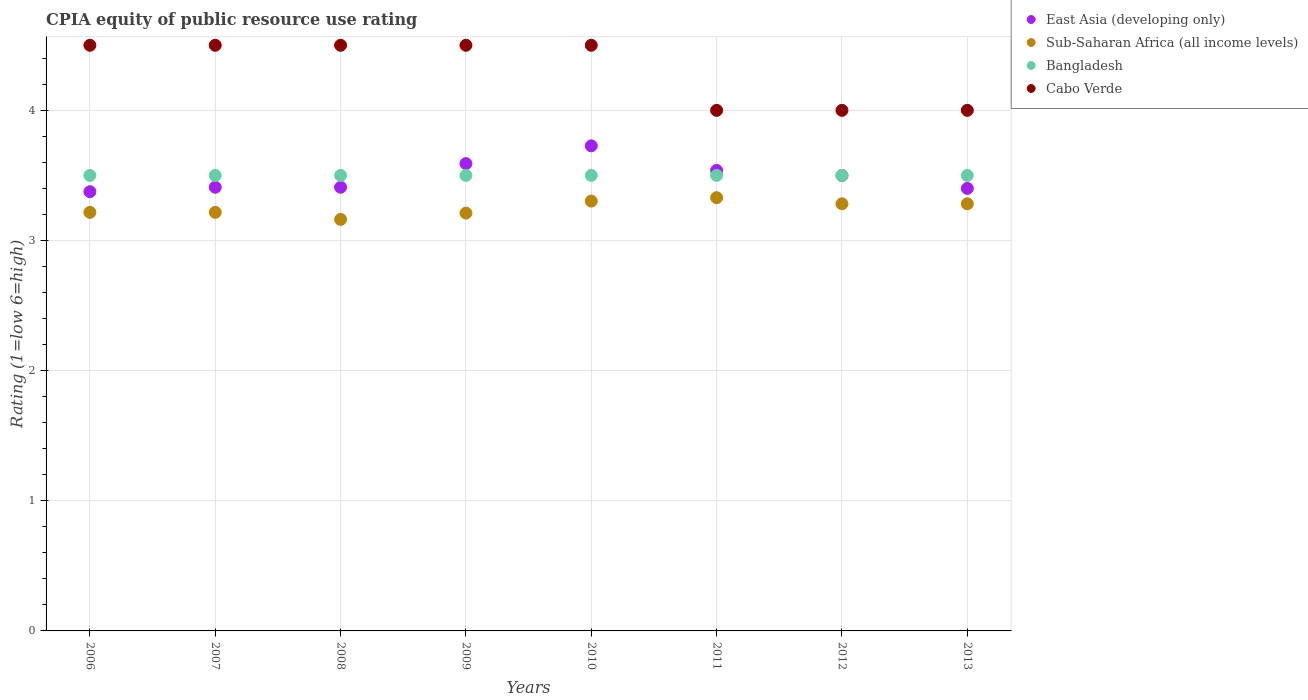How many different coloured dotlines are there?
Provide a short and direct response. 4. Is the number of dotlines equal to the number of legend labels?
Give a very brief answer. Yes. What is the CPIA rating in Sub-Saharan Africa (all income levels) in 2009?
Offer a terse response. 3.21. Across all years, what is the minimum CPIA rating in Sub-Saharan Africa (all income levels)?
Your answer should be compact. 3.16. In which year was the CPIA rating in Bangladesh maximum?
Give a very brief answer. 2006. What is the total CPIA rating in East Asia (developing only) in the graph?
Your response must be concise. 27.95. What is the difference between the CPIA rating in Bangladesh in 2011 and the CPIA rating in Cabo Verde in 2012?
Ensure brevity in your answer.  -0.5. What is the average CPIA rating in Sub-Saharan Africa (all income levels) per year?
Provide a short and direct response. 3.25. In the year 2008, what is the difference between the CPIA rating in Bangladesh and CPIA rating in East Asia (developing only)?
Offer a very short reply. 0.09. In how many years, is the CPIA rating in Cabo Verde greater than 1.8?
Your answer should be very brief. 8. What is the ratio of the CPIA rating in Sub-Saharan Africa (all income levels) in 2007 to that in 2009?
Give a very brief answer. 1. Is the CPIA rating in East Asia (developing only) in 2008 less than that in 2012?
Ensure brevity in your answer.  Yes. Is the difference between the CPIA rating in Bangladesh in 2008 and 2012 greater than the difference between the CPIA rating in East Asia (developing only) in 2008 and 2012?
Provide a succinct answer. Yes. What is the difference between the highest and the second highest CPIA rating in East Asia (developing only)?
Your answer should be very brief. 0.14. Is it the case that in every year, the sum of the CPIA rating in Bangladesh and CPIA rating in Cabo Verde  is greater than the sum of CPIA rating in East Asia (developing only) and CPIA rating in Sub-Saharan Africa (all income levels)?
Offer a very short reply. Yes. Is it the case that in every year, the sum of the CPIA rating in East Asia (developing only) and CPIA rating in Sub-Saharan Africa (all income levels)  is greater than the CPIA rating in Bangladesh?
Your response must be concise. Yes. Is the CPIA rating in Sub-Saharan Africa (all income levels) strictly greater than the CPIA rating in Bangladesh over the years?
Provide a succinct answer. No. Is the CPIA rating in Bangladesh strictly less than the CPIA rating in Cabo Verde over the years?
Make the answer very short. Yes. How many dotlines are there?
Your response must be concise. 4. How many years are there in the graph?
Keep it short and to the point. 8. Are the values on the major ticks of Y-axis written in scientific E-notation?
Your answer should be compact. No. Does the graph contain any zero values?
Provide a succinct answer. No. Does the graph contain grids?
Your answer should be very brief. Yes. What is the title of the graph?
Provide a succinct answer. CPIA equity of public resource use rating. Does "United States" appear as one of the legend labels in the graph?
Offer a very short reply. No. What is the label or title of the X-axis?
Make the answer very short. Years. What is the label or title of the Y-axis?
Give a very brief answer. Rating (1=low 6=high). What is the Rating (1=low 6=high) of East Asia (developing only) in 2006?
Make the answer very short. 3.38. What is the Rating (1=low 6=high) of Sub-Saharan Africa (all income levels) in 2006?
Ensure brevity in your answer.  3.22. What is the Rating (1=low 6=high) in Bangladesh in 2006?
Offer a terse response. 3.5. What is the Rating (1=low 6=high) in East Asia (developing only) in 2007?
Ensure brevity in your answer.  3.41. What is the Rating (1=low 6=high) of Sub-Saharan Africa (all income levels) in 2007?
Provide a short and direct response. 3.22. What is the Rating (1=low 6=high) in Bangladesh in 2007?
Your response must be concise. 3.5. What is the Rating (1=low 6=high) of East Asia (developing only) in 2008?
Your response must be concise. 3.41. What is the Rating (1=low 6=high) in Sub-Saharan Africa (all income levels) in 2008?
Your response must be concise. 3.16. What is the Rating (1=low 6=high) of Cabo Verde in 2008?
Offer a terse response. 4.5. What is the Rating (1=low 6=high) of East Asia (developing only) in 2009?
Give a very brief answer. 3.59. What is the Rating (1=low 6=high) of Sub-Saharan Africa (all income levels) in 2009?
Offer a very short reply. 3.21. What is the Rating (1=low 6=high) of Cabo Verde in 2009?
Your answer should be very brief. 4.5. What is the Rating (1=low 6=high) of East Asia (developing only) in 2010?
Make the answer very short. 3.73. What is the Rating (1=low 6=high) in Sub-Saharan Africa (all income levels) in 2010?
Provide a short and direct response. 3.3. What is the Rating (1=low 6=high) in Bangladesh in 2010?
Provide a succinct answer. 3.5. What is the Rating (1=low 6=high) of East Asia (developing only) in 2011?
Ensure brevity in your answer.  3.54. What is the Rating (1=low 6=high) of Sub-Saharan Africa (all income levels) in 2011?
Provide a short and direct response. 3.33. What is the Rating (1=low 6=high) of Cabo Verde in 2011?
Provide a short and direct response. 4. What is the Rating (1=low 6=high) in Sub-Saharan Africa (all income levels) in 2012?
Keep it short and to the point. 3.28. What is the Rating (1=low 6=high) in Bangladesh in 2012?
Your response must be concise. 3.5. What is the Rating (1=low 6=high) of Cabo Verde in 2012?
Provide a short and direct response. 4. What is the Rating (1=low 6=high) in Sub-Saharan Africa (all income levels) in 2013?
Offer a very short reply. 3.28. What is the Rating (1=low 6=high) of Cabo Verde in 2013?
Your answer should be compact. 4. Across all years, what is the maximum Rating (1=low 6=high) of East Asia (developing only)?
Provide a short and direct response. 3.73. Across all years, what is the maximum Rating (1=low 6=high) of Sub-Saharan Africa (all income levels)?
Your response must be concise. 3.33. Across all years, what is the minimum Rating (1=low 6=high) of East Asia (developing only)?
Your answer should be very brief. 3.38. Across all years, what is the minimum Rating (1=low 6=high) of Sub-Saharan Africa (all income levels)?
Give a very brief answer. 3.16. Across all years, what is the minimum Rating (1=low 6=high) of Bangladesh?
Ensure brevity in your answer.  3.5. What is the total Rating (1=low 6=high) of East Asia (developing only) in the graph?
Give a very brief answer. 27.95. What is the total Rating (1=low 6=high) of Sub-Saharan Africa (all income levels) in the graph?
Provide a short and direct response. 26. What is the total Rating (1=low 6=high) of Cabo Verde in the graph?
Make the answer very short. 34.5. What is the difference between the Rating (1=low 6=high) in East Asia (developing only) in 2006 and that in 2007?
Your response must be concise. -0.03. What is the difference between the Rating (1=low 6=high) in East Asia (developing only) in 2006 and that in 2008?
Keep it short and to the point. -0.03. What is the difference between the Rating (1=low 6=high) of Sub-Saharan Africa (all income levels) in 2006 and that in 2008?
Your answer should be very brief. 0.05. What is the difference between the Rating (1=low 6=high) of East Asia (developing only) in 2006 and that in 2009?
Your answer should be compact. -0.22. What is the difference between the Rating (1=low 6=high) of Sub-Saharan Africa (all income levels) in 2006 and that in 2009?
Provide a succinct answer. 0.01. What is the difference between the Rating (1=low 6=high) of Bangladesh in 2006 and that in 2009?
Your answer should be very brief. 0. What is the difference between the Rating (1=low 6=high) of Cabo Verde in 2006 and that in 2009?
Offer a terse response. 0. What is the difference between the Rating (1=low 6=high) of East Asia (developing only) in 2006 and that in 2010?
Offer a very short reply. -0.35. What is the difference between the Rating (1=low 6=high) in Sub-Saharan Africa (all income levels) in 2006 and that in 2010?
Your answer should be very brief. -0.09. What is the difference between the Rating (1=low 6=high) of Cabo Verde in 2006 and that in 2010?
Offer a very short reply. 0. What is the difference between the Rating (1=low 6=high) of East Asia (developing only) in 2006 and that in 2011?
Ensure brevity in your answer.  -0.16. What is the difference between the Rating (1=low 6=high) of Sub-Saharan Africa (all income levels) in 2006 and that in 2011?
Make the answer very short. -0.11. What is the difference between the Rating (1=low 6=high) in Bangladesh in 2006 and that in 2011?
Ensure brevity in your answer.  0. What is the difference between the Rating (1=low 6=high) in Cabo Verde in 2006 and that in 2011?
Provide a succinct answer. 0.5. What is the difference between the Rating (1=low 6=high) of East Asia (developing only) in 2006 and that in 2012?
Offer a very short reply. -0.12. What is the difference between the Rating (1=low 6=high) in Sub-Saharan Africa (all income levels) in 2006 and that in 2012?
Offer a terse response. -0.07. What is the difference between the Rating (1=low 6=high) of Bangladesh in 2006 and that in 2012?
Make the answer very short. 0. What is the difference between the Rating (1=low 6=high) of Cabo Verde in 2006 and that in 2012?
Offer a very short reply. 0.5. What is the difference between the Rating (1=low 6=high) of East Asia (developing only) in 2006 and that in 2013?
Your answer should be very brief. -0.03. What is the difference between the Rating (1=low 6=high) in Sub-Saharan Africa (all income levels) in 2006 and that in 2013?
Offer a terse response. -0.07. What is the difference between the Rating (1=low 6=high) in Cabo Verde in 2006 and that in 2013?
Provide a short and direct response. 0.5. What is the difference between the Rating (1=low 6=high) of Sub-Saharan Africa (all income levels) in 2007 and that in 2008?
Provide a short and direct response. 0.05. What is the difference between the Rating (1=low 6=high) in East Asia (developing only) in 2007 and that in 2009?
Your answer should be very brief. -0.18. What is the difference between the Rating (1=low 6=high) in Sub-Saharan Africa (all income levels) in 2007 and that in 2009?
Your answer should be compact. 0.01. What is the difference between the Rating (1=low 6=high) in East Asia (developing only) in 2007 and that in 2010?
Keep it short and to the point. -0.32. What is the difference between the Rating (1=low 6=high) of Sub-Saharan Africa (all income levels) in 2007 and that in 2010?
Your answer should be compact. -0.09. What is the difference between the Rating (1=low 6=high) in Cabo Verde in 2007 and that in 2010?
Provide a short and direct response. 0. What is the difference between the Rating (1=low 6=high) in East Asia (developing only) in 2007 and that in 2011?
Keep it short and to the point. -0.13. What is the difference between the Rating (1=low 6=high) of Sub-Saharan Africa (all income levels) in 2007 and that in 2011?
Your answer should be very brief. -0.11. What is the difference between the Rating (1=low 6=high) of Cabo Verde in 2007 and that in 2011?
Offer a very short reply. 0.5. What is the difference between the Rating (1=low 6=high) of East Asia (developing only) in 2007 and that in 2012?
Make the answer very short. -0.09. What is the difference between the Rating (1=low 6=high) of Sub-Saharan Africa (all income levels) in 2007 and that in 2012?
Offer a terse response. -0.07. What is the difference between the Rating (1=low 6=high) of Bangladesh in 2007 and that in 2012?
Keep it short and to the point. 0. What is the difference between the Rating (1=low 6=high) in Cabo Verde in 2007 and that in 2012?
Provide a succinct answer. 0.5. What is the difference between the Rating (1=low 6=high) of East Asia (developing only) in 2007 and that in 2013?
Your answer should be compact. 0.01. What is the difference between the Rating (1=low 6=high) in Sub-Saharan Africa (all income levels) in 2007 and that in 2013?
Provide a short and direct response. -0.07. What is the difference between the Rating (1=low 6=high) in Cabo Verde in 2007 and that in 2013?
Provide a succinct answer. 0.5. What is the difference between the Rating (1=low 6=high) of East Asia (developing only) in 2008 and that in 2009?
Provide a short and direct response. -0.18. What is the difference between the Rating (1=low 6=high) in Sub-Saharan Africa (all income levels) in 2008 and that in 2009?
Your response must be concise. -0.05. What is the difference between the Rating (1=low 6=high) of Bangladesh in 2008 and that in 2009?
Offer a terse response. 0. What is the difference between the Rating (1=low 6=high) in East Asia (developing only) in 2008 and that in 2010?
Give a very brief answer. -0.32. What is the difference between the Rating (1=low 6=high) in Sub-Saharan Africa (all income levels) in 2008 and that in 2010?
Offer a terse response. -0.14. What is the difference between the Rating (1=low 6=high) of Bangladesh in 2008 and that in 2010?
Your answer should be very brief. 0. What is the difference between the Rating (1=low 6=high) of East Asia (developing only) in 2008 and that in 2011?
Offer a very short reply. -0.13. What is the difference between the Rating (1=low 6=high) in Sub-Saharan Africa (all income levels) in 2008 and that in 2011?
Make the answer very short. -0.17. What is the difference between the Rating (1=low 6=high) in Cabo Verde in 2008 and that in 2011?
Offer a very short reply. 0.5. What is the difference between the Rating (1=low 6=high) in East Asia (developing only) in 2008 and that in 2012?
Provide a short and direct response. -0.09. What is the difference between the Rating (1=low 6=high) of Sub-Saharan Africa (all income levels) in 2008 and that in 2012?
Ensure brevity in your answer.  -0.12. What is the difference between the Rating (1=low 6=high) of Bangladesh in 2008 and that in 2012?
Keep it short and to the point. 0. What is the difference between the Rating (1=low 6=high) in Cabo Verde in 2008 and that in 2012?
Offer a terse response. 0.5. What is the difference between the Rating (1=low 6=high) of East Asia (developing only) in 2008 and that in 2013?
Ensure brevity in your answer.  0.01. What is the difference between the Rating (1=low 6=high) in Sub-Saharan Africa (all income levels) in 2008 and that in 2013?
Your response must be concise. -0.12. What is the difference between the Rating (1=low 6=high) of Bangladesh in 2008 and that in 2013?
Your answer should be very brief. 0. What is the difference between the Rating (1=low 6=high) in Cabo Verde in 2008 and that in 2013?
Provide a succinct answer. 0.5. What is the difference between the Rating (1=low 6=high) of East Asia (developing only) in 2009 and that in 2010?
Your answer should be compact. -0.14. What is the difference between the Rating (1=low 6=high) in Sub-Saharan Africa (all income levels) in 2009 and that in 2010?
Your response must be concise. -0.09. What is the difference between the Rating (1=low 6=high) of Bangladesh in 2009 and that in 2010?
Your answer should be compact. 0. What is the difference between the Rating (1=low 6=high) of East Asia (developing only) in 2009 and that in 2011?
Provide a succinct answer. 0.05. What is the difference between the Rating (1=low 6=high) in Sub-Saharan Africa (all income levels) in 2009 and that in 2011?
Your response must be concise. -0.12. What is the difference between the Rating (1=low 6=high) of Cabo Verde in 2009 and that in 2011?
Your answer should be very brief. 0.5. What is the difference between the Rating (1=low 6=high) of East Asia (developing only) in 2009 and that in 2012?
Your answer should be compact. 0.09. What is the difference between the Rating (1=low 6=high) of Sub-Saharan Africa (all income levels) in 2009 and that in 2012?
Provide a succinct answer. -0.07. What is the difference between the Rating (1=low 6=high) in East Asia (developing only) in 2009 and that in 2013?
Give a very brief answer. 0.19. What is the difference between the Rating (1=low 6=high) of Sub-Saharan Africa (all income levels) in 2009 and that in 2013?
Provide a succinct answer. -0.07. What is the difference between the Rating (1=low 6=high) of Bangladesh in 2009 and that in 2013?
Give a very brief answer. 0. What is the difference between the Rating (1=low 6=high) in East Asia (developing only) in 2010 and that in 2011?
Give a very brief answer. 0.19. What is the difference between the Rating (1=low 6=high) in Sub-Saharan Africa (all income levels) in 2010 and that in 2011?
Keep it short and to the point. -0.03. What is the difference between the Rating (1=low 6=high) in Bangladesh in 2010 and that in 2011?
Provide a succinct answer. 0. What is the difference between the Rating (1=low 6=high) in East Asia (developing only) in 2010 and that in 2012?
Offer a terse response. 0.23. What is the difference between the Rating (1=low 6=high) in Sub-Saharan Africa (all income levels) in 2010 and that in 2012?
Provide a succinct answer. 0.02. What is the difference between the Rating (1=low 6=high) in East Asia (developing only) in 2010 and that in 2013?
Provide a short and direct response. 0.33. What is the difference between the Rating (1=low 6=high) of Sub-Saharan Africa (all income levels) in 2010 and that in 2013?
Your answer should be compact. 0.02. What is the difference between the Rating (1=low 6=high) of Bangladesh in 2010 and that in 2013?
Make the answer very short. 0. What is the difference between the Rating (1=low 6=high) in Cabo Verde in 2010 and that in 2013?
Your answer should be compact. 0.5. What is the difference between the Rating (1=low 6=high) in East Asia (developing only) in 2011 and that in 2012?
Your response must be concise. 0.04. What is the difference between the Rating (1=low 6=high) of Sub-Saharan Africa (all income levels) in 2011 and that in 2012?
Your answer should be very brief. 0.05. What is the difference between the Rating (1=low 6=high) in East Asia (developing only) in 2011 and that in 2013?
Your answer should be very brief. 0.14. What is the difference between the Rating (1=low 6=high) of Sub-Saharan Africa (all income levels) in 2011 and that in 2013?
Make the answer very short. 0.05. What is the difference between the Rating (1=low 6=high) in Bangladesh in 2011 and that in 2013?
Provide a short and direct response. 0. What is the difference between the Rating (1=low 6=high) of Cabo Verde in 2011 and that in 2013?
Provide a succinct answer. 0. What is the difference between the Rating (1=low 6=high) of East Asia (developing only) in 2012 and that in 2013?
Ensure brevity in your answer.  0.1. What is the difference between the Rating (1=low 6=high) in East Asia (developing only) in 2006 and the Rating (1=low 6=high) in Sub-Saharan Africa (all income levels) in 2007?
Provide a succinct answer. 0.16. What is the difference between the Rating (1=low 6=high) in East Asia (developing only) in 2006 and the Rating (1=low 6=high) in Bangladesh in 2007?
Make the answer very short. -0.12. What is the difference between the Rating (1=low 6=high) of East Asia (developing only) in 2006 and the Rating (1=low 6=high) of Cabo Verde in 2007?
Provide a succinct answer. -1.12. What is the difference between the Rating (1=low 6=high) in Sub-Saharan Africa (all income levels) in 2006 and the Rating (1=low 6=high) in Bangladesh in 2007?
Your answer should be compact. -0.28. What is the difference between the Rating (1=low 6=high) in Sub-Saharan Africa (all income levels) in 2006 and the Rating (1=low 6=high) in Cabo Verde in 2007?
Offer a very short reply. -1.28. What is the difference between the Rating (1=low 6=high) in East Asia (developing only) in 2006 and the Rating (1=low 6=high) in Sub-Saharan Africa (all income levels) in 2008?
Offer a terse response. 0.21. What is the difference between the Rating (1=low 6=high) in East Asia (developing only) in 2006 and the Rating (1=low 6=high) in Bangladesh in 2008?
Provide a succinct answer. -0.12. What is the difference between the Rating (1=low 6=high) in East Asia (developing only) in 2006 and the Rating (1=low 6=high) in Cabo Verde in 2008?
Provide a succinct answer. -1.12. What is the difference between the Rating (1=low 6=high) of Sub-Saharan Africa (all income levels) in 2006 and the Rating (1=low 6=high) of Bangladesh in 2008?
Your response must be concise. -0.28. What is the difference between the Rating (1=low 6=high) in Sub-Saharan Africa (all income levels) in 2006 and the Rating (1=low 6=high) in Cabo Verde in 2008?
Your answer should be very brief. -1.28. What is the difference between the Rating (1=low 6=high) of East Asia (developing only) in 2006 and the Rating (1=low 6=high) of Sub-Saharan Africa (all income levels) in 2009?
Ensure brevity in your answer.  0.16. What is the difference between the Rating (1=low 6=high) in East Asia (developing only) in 2006 and the Rating (1=low 6=high) in Bangladesh in 2009?
Give a very brief answer. -0.12. What is the difference between the Rating (1=low 6=high) in East Asia (developing only) in 2006 and the Rating (1=low 6=high) in Cabo Verde in 2009?
Offer a very short reply. -1.12. What is the difference between the Rating (1=low 6=high) of Sub-Saharan Africa (all income levels) in 2006 and the Rating (1=low 6=high) of Bangladesh in 2009?
Offer a very short reply. -0.28. What is the difference between the Rating (1=low 6=high) of Sub-Saharan Africa (all income levels) in 2006 and the Rating (1=low 6=high) of Cabo Verde in 2009?
Make the answer very short. -1.28. What is the difference between the Rating (1=low 6=high) of East Asia (developing only) in 2006 and the Rating (1=low 6=high) of Sub-Saharan Africa (all income levels) in 2010?
Provide a succinct answer. 0.07. What is the difference between the Rating (1=low 6=high) of East Asia (developing only) in 2006 and the Rating (1=low 6=high) of Bangladesh in 2010?
Provide a short and direct response. -0.12. What is the difference between the Rating (1=low 6=high) in East Asia (developing only) in 2006 and the Rating (1=low 6=high) in Cabo Verde in 2010?
Provide a succinct answer. -1.12. What is the difference between the Rating (1=low 6=high) in Sub-Saharan Africa (all income levels) in 2006 and the Rating (1=low 6=high) in Bangladesh in 2010?
Your answer should be very brief. -0.28. What is the difference between the Rating (1=low 6=high) in Sub-Saharan Africa (all income levels) in 2006 and the Rating (1=low 6=high) in Cabo Verde in 2010?
Provide a succinct answer. -1.28. What is the difference between the Rating (1=low 6=high) in East Asia (developing only) in 2006 and the Rating (1=low 6=high) in Sub-Saharan Africa (all income levels) in 2011?
Provide a succinct answer. 0.05. What is the difference between the Rating (1=low 6=high) in East Asia (developing only) in 2006 and the Rating (1=low 6=high) in Bangladesh in 2011?
Your answer should be compact. -0.12. What is the difference between the Rating (1=low 6=high) of East Asia (developing only) in 2006 and the Rating (1=low 6=high) of Cabo Verde in 2011?
Your answer should be very brief. -0.62. What is the difference between the Rating (1=low 6=high) in Sub-Saharan Africa (all income levels) in 2006 and the Rating (1=low 6=high) in Bangladesh in 2011?
Your answer should be compact. -0.28. What is the difference between the Rating (1=low 6=high) in Sub-Saharan Africa (all income levels) in 2006 and the Rating (1=low 6=high) in Cabo Verde in 2011?
Make the answer very short. -0.78. What is the difference between the Rating (1=low 6=high) of Bangladesh in 2006 and the Rating (1=low 6=high) of Cabo Verde in 2011?
Your answer should be very brief. -0.5. What is the difference between the Rating (1=low 6=high) of East Asia (developing only) in 2006 and the Rating (1=low 6=high) of Sub-Saharan Africa (all income levels) in 2012?
Your response must be concise. 0.09. What is the difference between the Rating (1=low 6=high) in East Asia (developing only) in 2006 and the Rating (1=low 6=high) in Bangladesh in 2012?
Offer a terse response. -0.12. What is the difference between the Rating (1=low 6=high) of East Asia (developing only) in 2006 and the Rating (1=low 6=high) of Cabo Verde in 2012?
Keep it short and to the point. -0.62. What is the difference between the Rating (1=low 6=high) in Sub-Saharan Africa (all income levels) in 2006 and the Rating (1=low 6=high) in Bangladesh in 2012?
Your answer should be very brief. -0.28. What is the difference between the Rating (1=low 6=high) of Sub-Saharan Africa (all income levels) in 2006 and the Rating (1=low 6=high) of Cabo Verde in 2012?
Your response must be concise. -0.78. What is the difference between the Rating (1=low 6=high) in East Asia (developing only) in 2006 and the Rating (1=low 6=high) in Sub-Saharan Africa (all income levels) in 2013?
Make the answer very short. 0.09. What is the difference between the Rating (1=low 6=high) in East Asia (developing only) in 2006 and the Rating (1=low 6=high) in Bangladesh in 2013?
Provide a short and direct response. -0.12. What is the difference between the Rating (1=low 6=high) in East Asia (developing only) in 2006 and the Rating (1=low 6=high) in Cabo Verde in 2013?
Give a very brief answer. -0.62. What is the difference between the Rating (1=low 6=high) of Sub-Saharan Africa (all income levels) in 2006 and the Rating (1=low 6=high) of Bangladesh in 2013?
Your response must be concise. -0.28. What is the difference between the Rating (1=low 6=high) in Sub-Saharan Africa (all income levels) in 2006 and the Rating (1=low 6=high) in Cabo Verde in 2013?
Make the answer very short. -0.78. What is the difference between the Rating (1=low 6=high) in Bangladesh in 2006 and the Rating (1=low 6=high) in Cabo Verde in 2013?
Make the answer very short. -0.5. What is the difference between the Rating (1=low 6=high) in East Asia (developing only) in 2007 and the Rating (1=low 6=high) in Sub-Saharan Africa (all income levels) in 2008?
Offer a terse response. 0.25. What is the difference between the Rating (1=low 6=high) in East Asia (developing only) in 2007 and the Rating (1=low 6=high) in Bangladesh in 2008?
Ensure brevity in your answer.  -0.09. What is the difference between the Rating (1=low 6=high) in East Asia (developing only) in 2007 and the Rating (1=low 6=high) in Cabo Verde in 2008?
Provide a short and direct response. -1.09. What is the difference between the Rating (1=low 6=high) of Sub-Saharan Africa (all income levels) in 2007 and the Rating (1=low 6=high) of Bangladesh in 2008?
Keep it short and to the point. -0.28. What is the difference between the Rating (1=low 6=high) of Sub-Saharan Africa (all income levels) in 2007 and the Rating (1=low 6=high) of Cabo Verde in 2008?
Offer a very short reply. -1.28. What is the difference between the Rating (1=low 6=high) of East Asia (developing only) in 2007 and the Rating (1=low 6=high) of Sub-Saharan Africa (all income levels) in 2009?
Keep it short and to the point. 0.2. What is the difference between the Rating (1=low 6=high) in East Asia (developing only) in 2007 and the Rating (1=low 6=high) in Bangladesh in 2009?
Your answer should be very brief. -0.09. What is the difference between the Rating (1=low 6=high) of East Asia (developing only) in 2007 and the Rating (1=low 6=high) of Cabo Verde in 2009?
Offer a terse response. -1.09. What is the difference between the Rating (1=low 6=high) in Sub-Saharan Africa (all income levels) in 2007 and the Rating (1=low 6=high) in Bangladesh in 2009?
Give a very brief answer. -0.28. What is the difference between the Rating (1=low 6=high) in Sub-Saharan Africa (all income levels) in 2007 and the Rating (1=low 6=high) in Cabo Verde in 2009?
Your answer should be compact. -1.28. What is the difference between the Rating (1=low 6=high) of Bangladesh in 2007 and the Rating (1=low 6=high) of Cabo Verde in 2009?
Offer a terse response. -1. What is the difference between the Rating (1=low 6=high) of East Asia (developing only) in 2007 and the Rating (1=low 6=high) of Sub-Saharan Africa (all income levels) in 2010?
Your answer should be very brief. 0.11. What is the difference between the Rating (1=low 6=high) of East Asia (developing only) in 2007 and the Rating (1=low 6=high) of Bangladesh in 2010?
Keep it short and to the point. -0.09. What is the difference between the Rating (1=low 6=high) in East Asia (developing only) in 2007 and the Rating (1=low 6=high) in Cabo Verde in 2010?
Keep it short and to the point. -1.09. What is the difference between the Rating (1=low 6=high) of Sub-Saharan Africa (all income levels) in 2007 and the Rating (1=low 6=high) of Bangladesh in 2010?
Ensure brevity in your answer.  -0.28. What is the difference between the Rating (1=low 6=high) of Sub-Saharan Africa (all income levels) in 2007 and the Rating (1=low 6=high) of Cabo Verde in 2010?
Ensure brevity in your answer.  -1.28. What is the difference between the Rating (1=low 6=high) in Bangladesh in 2007 and the Rating (1=low 6=high) in Cabo Verde in 2010?
Your answer should be compact. -1. What is the difference between the Rating (1=low 6=high) of East Asia (developing only) in 2007 and the Rating (1=low 6=high) of Sub-Saharan Africa (all income levels) in 2011?
Keep it short and to the point. 0.08. What is the difference between the Rating (1=low 6=high) of East Asia (developing only) in 2007 and the Rating (1=low 6=high) of Bangladesh in 2011?
Offer a very short reply. -0.09. What is the difference between the Rating (1=low 6=high) in East Asia (developing only) in 2007 and the Rating (1=low 6=high) in Cabo Verde in 2011?
Offer a terse response. -0.59. What is the difference between the Rating (1=low 6=high) in Sub-Saharan Africa (all income levels) in 2007 and the Rating (1=low 6=high) in Bangladesh in 2011?
Ensure brevity in your answer.  -0.28. What is the difference between the Rating (1=low 6=high) in Sub-Saharan Africa (all income levels) in 2007 and the Rating (1=low 6=high) in Cabo Verde in 2011?
Give a very brief answer. -0.78. What is the difference between the Rating (1=low 6=high) in Bangladesh in 2007 and the Rating (1=low 6=high) in Cabo Verde in 2011?
Provide a succinct answer. -0.5. What is the difference between the Rating (1=low 6=high) in East Asia (developing only) in 2007 and the Rating (1=low 6=high) in Sub-Saharan Africa (all income levels) in 2012?
Your answer should be very brief. 0.13. What is the difference between the Rating (1=low 6=high) of East Asia (developing only) in 2007 and the Rating (1=low 6=high) of Bangladesh in 2012?
Offer a very short reply. -0.09. What is the difference between the Rating (1=low 6=high) of East Asia (developing only) in 2007 and the Rating (1=low 6=high) of Cabo Verde in 2012?
Your answer should be very brief. -0.59. What is the difference between the Rating (1=low 6=high) in Sub-Saharan Africa (all income levels) in 2007 and the Rating (1=low 6=high) in Bangladesh in 2012?
Make the answer very short. -0.28. What is the difference between the Rating (1=low 6=high) in Sub-Saharan Africa (all income levels) in 2007 and the Rating (1=low 6=high) in Cabo Verde in 2012?
Offer a very short reply. -0.78. What is the difference between the Rating (1=low 6=high) of Bangladesh in 2007 and the Rating (1=low 6=high) of Cabo Verde in 2012?
Ensure brevity in your answer.  -0.5. What is the difference between the Rating (1=low 6=high) of East Asia (developing only) in 2007 and the Rating (1=low 6=high) of Sub-Saharan Africa (all income levels) in 2013?
Ensure brevity in your answer.  0.13. What is the difference between the Rating (1=low 6=high) in East Asia (developing only) in 2007 and the Rating (1=low 6=high) in Bangladesh in 2013?
Your answer should be very brief. -0.09. What is the difference between the Rating (1=low 6=high) of East Asia (developing only) in 2007 and the Rating (1=low 6=high) of Cabo Verde in 2013?
Offer a terse response. -0.59. What is the difference between the Rating (1=low 6=high) of Sub-Saharan Africa (all income levels) in 2007 and the Rating (1=low 6=high) of Bangladesh in 2013?
Ensure brevity in your answer.  -0.28. What is the difference between the Rating (1=low 6=high) in Sub-Saharan Africa (all income levels) in 2007 and the Rating (1=low 6=high) in Cabo Verde in 2013?
Give a very brief answer. -0.78. What is the difference between the Rating (1=low 6=high) in Bangladesh in 2007 and the Rating (1=low 6=high) in Cabo Verde in 2013?
Provide a succinct answer. -0.5. What is the difference between the Rating (1=low 6=high) of East Asia (developing only) in 2008 and the Rating (1=low 6=high) of Sub-Saharan Africa (all income levels) in 2009?
Make the answer very short. 0.2. What is the difference between the Rating (1=low 6=high) of East Asia (developing only) in 2008 and the Rating (1=low 6=high) of Bangladesh in 2009?
Your response must be concise. -0.09. What is the difference between the Rating (1=low 6=high) of East Asia (developing only) in 2008 and the Rating (1=low 6=high) of Cabo Verde in 2009?
Provide a short and direct response. -1.09. What is the difference between the Rating (1=low 6=high) in Sub-Saharan Africa (all income levels) in 2008 and the Rating (1=low 6=high) in Bangladesh in 2009?
Provide a succinct answer. -0.34. What is the difference between the Rating (1=low 6=high) of Sub-Saharan Africa (all income levels) in 2008 and the Rating (1=low 6=high) of Cabo Verde in 2009?
Provide a short and direct response. -1.34. What is the difference between the Rating (1=low 6=high) of East Asia (developing only) in 2008 and the Rating (1=low 6=high) of Sub-Saharan Africa (all income levels) in 2010?
Keep it short and to the point. 0.11. What is the difference between the Rating (1=low 6=high) in East Asia (developing only) in 2008 and the Rating (1=low 6=high) in Bangladesh in 2010?
Offer a terse response. -0.09. What is the difference between the Rating (1=low 6=high) of East Asia (developing only) in 2008 and the Rating (1=low 6=high) of Cabo Verde in 2010?
Offer a terse response. -1.09. What is the difference between the Rating (1=low 6=high) of Sub-Saharan Africa (all income levels) in 2008 and the Rating (1=low 6=high) of Bangladesh in 2010?
Provide a short and direct response. -0.34. What is the difference between the Rating (1=low 6=high) of Sub-Saharan Africa (all income levels) in 2008 and the Rating (1=low 6=high) of Cabo Verde in 2010?
Offer a very short reply. -1.34. What is the difference between the Rating (1=low 6=high) of Bangladesh in 2008 and the Rating (1=low 6=high) of Cabo Verde in 2010?
Keep it short and to the point. -1. What is the difference between the Rating (1=low 6=high) in East Asia (developing only) in 2008 and the Rating (1=low 6=high) in Sub-Saharan Africa (all income levels) in 2011?
Offer a terse response. 0.08. What is the difference between the Rating (1=low 6=high) in East Asia (developing only) in 2008 and the Rating (1=low 6=high) in Bangladesh in 2011?
Ensure brevity in your answer.  -0.09. What is the difference between the Rating (1=low 6=high) of East Asia (developing only) in 2008 and the Rating (1=low 6=high) of Cabo Verde in 2011?
Give a very brief answer. -0.59. What is the difference between the Rating (1=low 6=high) in Sub-Saharan Africa (all income levels) in 2008 and the Rating (1=low 6=high) in Bangladesh in 2011?
Your response must be concise. -0.34. What is the difference between the Rating (1=low 6=high) of Sub-Saharan Africa (all income levels) in 2008 and the Rating (1=low 6=high) of Cabo Verde in 2011?
Give a very brief answer. -0.84. What is the difference between the Rating (1=low 6=high) in Bangladesh in 2008 and the Rating (1=low 6=high) in Cabo Verde in 2011?
Your answer should be very brief. -0.5. What is the difference between the Rating (1=low 6=high) of East Asia (developing only) in 2008 and the Rating (1=low 6=high) of Sub-Saharan Africa (all income levels) in 2012?
Give a very brief answer. 0.13. What is the difference between the Rating (1=low 6=high) of East Asia (developing only) in 2008 and the Rating (1=low 6=high) of Bangladesh in 2012?
Your answer should be compact. -0.09. What is the difference between the Rating (1=low 6=high) in East Asia (developing only) in 2008 and the Rating (1=low 6=high) in Cabo Verde in 2012?
Your answer should be compact. -0.59. What is the difference between the Rating (1=low 6=high) in Sub-Saharan Africa (all income levels) in 2008 and the Rating (1=low 6=high) in Bangladesh in 2012?
Provide a short and direct response. -0.34. What is the difference between the Rating (1=low 6=high) of Sub-Saharan Africa (all income levels) in 2008 and the Rating (1=low 6=high) of Cabo Verde in 2012?
Provide a succinct answer. -0.84. What is the difference between the Rating (1=low 6=high) of East Asia (developing only) in 2008 and the Rating (1=low 6=high) of Sub-Saharan Africa (all income levels) in 2013?
Your answer should be very brief. 0.13. What is the difference between the Rating (1=low 6=high) in East Asia (developing only) in 2008 and the Rating (1=low 6=high) in Bangladesh in 2013?
Your answer should be compact. -0.09. What is the difference between the Rating (1=low 6=high) in East Asia (developing only) in 2008 and the Rating (1=low 6=high) in Cabo Verde in 2013?
Make the answer very short. -0.59. What is the difference between the Rating (1=low 6=high) in Sub-Saharan Africa (all income levels) in 2008 and the Rating (1=low 6=high) in Bangladesh in 2013?
Provide a succinct answer. -0.34. What is the difference between the Rating (1=low 6=high) in Sub-Saharan Africa (all income levels) in 2008 and the Rating (1=low 6=high) in Cabo Verde in 2013?
Give a very brief answer. -0.84. What is the difference between the Rating (1=low 6=high) of East Asia (developing only) in 2009 and the Rating (1=low 6=high) of Sub-Saharan Africa (all income levels) in 2010?
Your answer should be compact. 0.29. What is the difference between the Rating (1=low 6=high) in East Asia (developing only) in 2009 and the Rating (1=low 6=high) in Bangladesh in 2010?
Keep it short and to the point. 0.09. What is the difference between the Rating (1=low 6=high) in East Asia (developing only) in 2009 and the Rating (1=low 6=high) in Cabo Verde in 2010?
Offer a very short reply. -0.91. What is the difference between the Rating (1=low 6=high) of Sub-Saharan Africa (all income levels) in 2009 and the Rating (1=low 6=high) of Bangladesh in 2010?
Ensure brevity in your answer.  -0.29. What is the difference between the Rating (1=low 6=high) in Sub-Saharan Africa (all income levels) in 2009 and the Rating (1=low 6=high) in Cabo Verde in 2010?
Ensure brevity in your answer.  -1.29. What is the difference between the Rating (1=low 6=high) of East Asia (developing only) in 2009 and the Rating (1=low 6=high) of Sub-Saharan Africa (all income levels) in 2011?
Provide a succinct answer. 0.26. What is the difference between the Rating (1=low 6=high) in East Asia (developing only) in 2009 and the Rating (1=low 6=high) in Bangladesh in 2011?
Give a very brief answer. 0.09. What is the difference between the Rating (1=low 6=high) in East Asia (developing only) in 2009 and the Rating (1=low 6=high) in Cabo Verde in 2011?
Your response must be concise. -0.41. What is the difference between the Rating (1=low 6=high) of Sub-Saharan Africa (all income levels) in 2009 and the Rating (1=low 6=high) of Bangladesh in 2011?
Your response must be concise. -0.29. What is the difference between the Rating (1=low 6=high) of Sub-Saharan Africa (all income levels) in 2009 and the Rating (1=low 6=high) of Cabo Verde in 2011?
Provide a succinct answer. -0.79. What is the difference between the Rating (1=low 6=high) of East Asia (developing only) in 2009 and the Rating (1=low 6=high) of Sub-Saharan Africa (all income levels) in 2012?
Keep it short and to the point. 0.31. What is the difference between the Rating (1=low 6=high) of East Asia (developing only) in 2009 and the Rating (1=low 6=high) of Bangladesh in 2012?
Your answer should be very brief. 0.09. What is the difference between the Rating (1=low 6=high) of East Asia (developing only) in 2009 and the Rating (1=low 6=high) of Cabo Verde in 2012?
Offer a very short reply. -0.41. What is the difference between the Rating (1=low 6=high) in Sub-Saharan Africa (all income levels) in 2009 and the Rating (1=low 6=high) in Bangladesh in 2012?
Your answer should be compact. -0.29. What is the difference between the Rating (1=low 6=high) of Sub-Saharan Africa (all income levels) in 2009 and the Rating (1=low 6=high) of Cabo Verde in 2012?
Provide a short and direct response. -0.79. What is the difference between the Rating (1=low 6=high) of East Asia (developing only) in 2009 and the Rating (1=low 6=high) of Sub-Saharan Africa (all income levels) in 2013?
Your answer should be very brief. 0.31. What is the difference between the Rating (1=low 6=high) of East Asia (developing only) in 2009 and the Rating (1=low 6=high) of Bangladesh in 2013?
Provide a succinct answer. 0.09. What is the difference between the Rating (1=low 6=high) in East Asia (developing only) in 2009 and the Rating (1=low 6=high) in Cabo Verde in 2013?
Your response must be concise. -0.41. What is the difference between the Rating (1=low 6=high) of Sub-Saharan Africa (all income levels) in 2009 and the Rating (1=low 6=high) of Bangladesh in 2013?
Offer a very short reply. -0.29. What is the difference between the Rating (1=low 6=high) in Sub-Saharan Africa (all income levels) in 2009 and the Rating (1=low 6=high) in Cabo Verde in 2013?
Offer a terse response. -0.79. What is the difference between the Rating (1=low 6=high) in Bangladesh in 2009 and the Rating (1=low 6=high) in Cabo Verde in 2013?
Give a very brief answer. -0.5. What is the difference between the Rating (1=low 6=high) of East Asia (developing only) in 2010 and the Rating (1=low 6=high) of Sub-Saharan Africa (all income levels) in 2011?
Make the answer very short. 0.4. What is the difference between the Rating (1=low 6=high) of East Asia (developing only) in 2010 and the Rating (1=low 6=high) of Bangladesh in 2011?
Offer a terse response. 0.23. What is the difference between the Rating (1=low 6=high) in East Asia (developing only) in 2010 and the Rating (1=low 6=high) in Cabo Verde in 2011?
Provide a succinct answer. -0.27. What is the difference between the Rating (1=low 6=high) in Sub-Saharan Africa (all income levels) in 2010 and the Rating (1=low 6=high) in Bangladesh in 2011?
Your response must be concise. -0.2. What is the difference between the Rating (1=low 6=high) in Sub-Saharan Africa (all income levels) in 2010 and the Rating (1=low 6=high) in Cabo Verde in 2011?
Provide a succinct answer. -0.7. What is the difference between the Rating (1=low 6=high) in Bangladesh in 2010 and the Rating (1=low 6=high) in Cabo Verde in 2011?
Make the answer very short. -0.5. What is the difference between the Rating (1=low 6=high) of East Asia (developing only) in 2010 and the Rating (1=low 6=high) of Sub-Saharan Africa (all income levels) in 2012?
Your answer should be compact. 0.45. What is the difference between the Rating (1=low 6=high) in East Asia (developing only) in 2010 and the Rating (1=low 6=high) in Bangladesh in 2012?
Provide a short and direct response. 0.23. What is the difference between the Rating (1=low 6=high) in East Asia (developing only) in 2010 and the Rating (1=low 6=high) in Cabo Verde in 2012?
Offer a terse response. -0.27. What is the difference between the Rating (1=low 6=high) of Sub-Saharan Africa (all income levels) in 2010 and the Rating (1=low 6=high) of Bangladesh in 2012?
Ensure brevity in your answer.  -0.2. What is the difference between the Rating (1=low 6=high) in Sub-Saharan Africa (all income levels) in 2010 and the Rating (1=low 6=high) in Cabo Verde in 2012?
Your answer should be very brief. -0.7. What is the difference between the Rating (1=low 6=high) of East Asia (developing only) in 2010 and the Rating (1=low 6=high) of Sub-Saharan Africa (all income levels) in 2013?
Give a very brief answer. 0.45. What is the difference between the Rating (1=low 6=high) in East Asia (developing only) in 2010 and the Rating (1=low 6=high) in Bangladesh in 2013?
Provide a succinct answer. 0.23. What is the difference between the Rating (1=low 6=high) of East Asia (developing only) in 2010 and the Rating (1=low 6=high) of Cabo Verde in 2013?
Your response must be concise. -0.27. What is the difference between the Rating (1=low 6=high) of Sub-Saharan Africa (all income levels) in 2010 and the Rating (1=low 6=high) of Bangladesh in 2013?
Provide a succinct answer. -0.2. What is the difference between the Rating (1=low 6=high) of Sub-Saharan Africa (all income levels) in 2010 and the Rating (1=low 6=high) of Cabo Verde in 2013?
Make the answer very short. -0.7. What is the difference between the Rating (1=low 6=high) of East Asia (developing only) in 2011 and the Rating (1=low 6=high) of Sub-Saharan Africa (all income levels) in 2012?
Your answer should be compact. 0.26. What is the difference between the Rating (1=low 6=high) of East Asia (developing only) in 2011 and the Rating (1=low 6=high) of Bangladesh in 2012?
Your answer should be compact. 0.04. What is the difference between the Rating (1=low 6=high) of East Asia (developing only) in 2011 and the Rating (1=low 6=high) of Cabo Verde in 2012?
Offer a terse response. -0.46. What is the difference between the Rating (1=low 6=high) of Sub-Saharan Africa (all income levels) in 2011 and the Rating (1=low 6=high) of Bangladesh in 2012?
Keep it short and to the point. -0.17. What is the difference between the Rating (1=low 6=high) in Sub-Saharan Africa (all income levels) in 2011 and the Rating (1=low 6=high) in Cabo Verde in 2012?
Your answer should be compact. -0.67. What is the difference between the Rating (1=low 6=high) of Bangladesh in 2011 and the Rating (1=low 6=high) of Cabo Verde in 2012?
Offer a very short reply. -0.5. What is the difference between the Rating (1=low 6=high) in East Asia (developing only) in 2011 and the Rating (1=low 6=high) in Sub-Saharan Africa (all income levels) in 2013?
Offer a terse response. 0.26. What is the difference between the Rating (1=low 6=high) of East Asia (developing only) in 2011 and the Rating (1=low 6=high) of Bangladesh in 2013?
Offer a very short reply. 0.04. What is the difference between the Rating (1=low 6=high) of East Asia (developing only) in 2011 and the Rating (1=low 6=high) of Cabo Verde in 2013?
Give a very brief answer. -0.46. What is the difference between the Rating (1=low 6=high) in Sub-Saharan Africa (all income levels) in 2011 and the Rating (1=low 6=high) in Bangladesh in 2013?
Your response must be concise. -0.17. What is the difference between the Rating (1=low 6=high) of Sub-Saharan Africa (all income levels) in 2011 and the Rating (1=low 6=high) of Cabo Verde in 2013?
Your answer should be very brief. -0.67. What is the difference between the Rating (1=low 6=high) in East Asia (developing only) in 2012 and the Rating (1=low 6=high) in Sub-Saharan Africa (all income levels) in 2013?
Offer a very short reply. 0.22. What is the difference between the Rating (1=low 6=high) of East Asia (developing only) in 2012 and the Rating (1=low 6=high) of Cabo Verde in 2013?
Your answer should be very brief. -0.5. What is the difference between the Rating (1=low 6=high) in Sub-Saharan Africa (all income levels) in 2012 and the Rating (1=low 6=high) in Bangladesh in 2013?
Keep it short and to the point. -0.22. What is the difference between the Rating (1=low 6=high) of Sub-Saharan Africa (all income levels) in 2012 and the Rating (1=low 6=high) of Cabo Verde in 2013?
Offer a very short reply. -0.72. What is the difference between the Rating (1=low 6=high) in Bangladesh in 2012 and the Rating (1=low 6=high) in Cabo Verde in 2013?
Ensure brevity in your answer.  -0.5. What is the average Rating (1=low 6=high) of East Asia (developing only) per year?
Give a very brief answer. 3.49. What is the average Rating (1=low 6=high) of Sub-Saharan Africa (all income levels) per year?
Give a very brief answer. 3.25. What is the average Rating (1=low 6=high) of Cabo Verde per year?
Your answer should be very brief. 4.31. In the year 2006, what is the difference between the Rating (1=low 6=high) in East Asia (developing only) and Rating (1=low 6=high) in Sub-Saharan Africa (all income levels)?
Provide a succinct answer. 0.16. In the year 2006, what is the difference between the Rating (1=low 6=high) in East Asia (developing only) and Rating (1=low 6=high) in Bangladesh?
Make the answer very short. -0.12. In the year 2006, what is the difference between the Rating (1=low 6=high) of East Asia (developing only) and Rating (1=low 6=high) of Cabo Verde?
Make the answer very short. -1.12. In the year 2006, what is the difference between the Rating (1=low 6=high) of Sub-Saharan Africa (all income levels) and Rating (1=low 6=high) of Bangladesh?
Your response must be concise. -0.28. In the year 2006, what is the difference between the Rating (1=low 6=high) of Sub-Saharan Africa (all income levels) and Rating (1=low 6=high) of Cabo Verde?
Your response must be concise. -1.28. In the year 2007, what is the difference between the Rating (1=low 6=high) of East Asia (developing only) and Rating (1=low 6=high) of Sub-Saharan Africa (all income levels)?
Offer a very short reply. 0.19. In the year 2007, what is the difference between the Rating (1=low 6=high) of East Asia (developing only) and Rating (1=low 6=high) of Bangladesh?
Provide a short and direct response. -0.09. In the year 2007, what is the difference between the Rating (1=low 6=high) of East Asia (developing only) and Rating (1=low 6=high) of Cabo Verde?
Your response must be concise. -1.09. In the year 2007, what is the difference between the Rating (1=low 6=high) in Sub-Saharan Africa (all income levels) and Rating (1=low 6=high) in Bangladesh?
Offer a very short reply. -0.28. In the year 2007, what is the difference between the Rating (1=low 6=high) in Sub-Saharan Africa (all income levels) and Rating (1=low 6=high) in Cabo Verde?
Your answer should be very brief. -1.28. In the year 2008, what is the difference between the Rating (1=low 6=high) in East Asia (developing only) and Rating (1=low 6=high) in Sub-Saharan Africa (all income levels)?
Your response must be concise. 0.25. In the year 2008, what is the difference between the Rating (1=low 6=high) of East Asia (developing only) and Rating (1=low 6=high) of Bangladesh?
Your response must be concise. -0.09. In the year 2008, what is the difference between the Rating (1=low 6=high) of East Asia (developing only) and Rating (1=low 6=high) of Cabo Verde?
Keep it short and to the point. -1.09. In the year 2008, what is the difference between the Rating (1=low 6=high) of Sub-Saharan Africa (all income levels) and Rating (1=low 6=high) of Bangladesh?
Give a very brief answer. -0.34. In the year 2008, what is the difference between the Rating (1=low 6=high) in Sub-Saharan Africa (all income levels) and Rating (1=low 6=high) in Cabo Verde?
Ensure brevity in your answer.  -1.34. In the year 2008, what is the difference between the Rating (1=low 6=high) in Bangladesh and Rating (1=low 6=high) in Cabo Verde?
Your response must be concise. -1. In the year 2009, what is the difference between the Rating (1=low 6=high) of East Asia (developing only) and Rating (1=low 6=high) of Sub-Saharan Africa (all income levels)?
Offer a terse response. 0.38. In the year 2009, what is the difference between the Rating (1=low 6=high) of East Asia (developing only) and Rating (1=low 6=high) of Bangladesh?
Offer a very short reply. 0.09. In the year 2009, what is the difference between the Rating (1=low 6=high) in East Asia (developing only) and Rating (1=low 6=high) in Cabo Verde?
Offer a very short reply. -0.91. In the year 2009, what is the difference between the Rating (1=low 6=high) of Sub-Saharan Africa (all income levels) and Rating (1=low 6=high) of Bangladesh?
Provide a short and direct response. -0.29. In the year 2009, what is the difference between the Rating (1=low 6=high) in Sub-Saharan Africa (all income levels) and Rating (1=low 6=high) in Cabo Verde?
Your answer should be compact. -1.29. In the year 2010, what is the difference between the Rating (1=low 6=high) of East Asia (developing only) and Rating (1=low 6=high) of Sub-Saharan Africa (all income levels)?
Your answer should be very brief. 0.42. In the year 2010, what is the difference between the Rating (1=low 6=high) of East Asia (developing only) and Rating (1=low 6=high) of Bangladesh?
Give a very brief answer. 0.23. In the year 2010, what is the difference between the Rating (1=low 6=high) of East Asia (developing only) and Rating (1=low 6=high) of Cabo Verde?
Provide a short and direct response. -0.77. In the year 2010, what is the difference between the Rating (1=low 6=high) of Sub-Saharan Africa (all income levels) and Rating (1=low 6=high) of Bangladesh?
Your response must be concise. -0.2. In the year 2010, what is the difference between the Rating (1=low 6=high) of Sub-Saharan Africa (all income levels) and Rating (1=low 6=high) of Cabo Verde?
Offer a terse response. -1.2. In the year 2011, what is the difference between the Rating (1=low 6=high) of East Asia (developing only) and Rating (1=low 6=high) of Sub-Saharan Africa (all income levels)?
Give a very brief answer. 0.21. In the year 2011, what is the difference between the Rating (1=low 6=high) in East Asia (developing only) and Rating (1=low 6=high) in Bangladesh?
Your answer should be compact. 0.04. In the year 2011, what is the difference between the Rating (1=low 6=high) of East Asia (developing only) and Rating (1=low 6=high) of Cabo Verde?
Your response must be concise. -0.46. In the year 2011, what is the difference between the Rating (1=low 6=high) of Sub-Saharan Africa (all income levels) and Rating (1=low 6=high) of Bangladesh?
Ensure brevity in your answer.  -0.17. In the year 2011, what is the difference between the Rating (1=low 6=high) in Sub-Saharan Africa (all income levels) and Rating (1=low 6=high) in Cabo Verde?
Offer a very short reply. -0.67. In the year 2012, what is the difference between the Rating (1=low 6=high) of East Asia (developing only) and Rating (1=low 6=high) of Sub-Saharan Africa (all income levels)?
Offer a terse response. 0.22. In the year 2012, what is the difference between the Rating (1=low 6=high) in Sub-Saharan Africa (all income levels) and Rating (1=low 6=high) in Bangladesh?
Keep it short and to the point. -0.22. In the year 2012, what is the difference between the Rating (1=low 6=high) in Sub-Saharan Africa (all income levels) and Rating (1=low 6=high) in Cabo Verde?
Your answer should be very brief. -0.72. In the year 2012, what is the difference between the Rating (1=low 6=high) of Bangladesh and Rating (1=low 6=high) of Cabo Verde?
Your answer should be very brief. -0.5. In the year 2013, what is the difference between the Rating (1=low 6=high) in East Asia (developing only) and Rating (1=low 6=high) in Sub-Saharan Africa (all income levels)?
Provide a short and direct response. 0.12. In the year 2013, what is the difference between the Rating (1=low 6=high) of East Asia (developing only) and Rating (1=low 6=high) of Bangladesh?
Offer a very short reply. -0.1. In the year 2013, what is the difference between the Rating (1=low 6=high) of Sub-Saharan Africa (all income levels) and Rating (1=low 6=high) of Bangladesh?
Keep it short and to the point. -0.22. In the year 2013, what is the difference between the Rating (1=low 6=high) in Sub-Saharan Africa (all income levels) and Rating (1=low 6=high) in Cabo Verde?
Ensure brevity in your answer.  -0.72. In the year 2013, what is the difference between the Rating (1=low 6=high) in Bangladesh and Rating (1=low 6=high) in Cabo Verde?
Your answer should be very brief. -0.5. What is the ratio of the Rating (1=low 6=high) of East Asia (developing only) in 2006 to that in 2007?
Give a very brief answer. 0.99. What is the ratio of the Rating (1=low 6=high) in Sub-Saharan Africa (all income levels) in 2006 to that in 2007?
Ensure brevity in your answer.  1. What is the ratio of the Rating (1=low 6=high) of Bangladesh in 2006 to that in 2007?
Keep it short and to the point. 1. What is the ratio of the Rating (1=low 6=high) in East Asia (developing only) in 2006 to that in 2008?
Ensure brevity in your answer.  0.99. What is the ratio of the Rating (1=low 6=high) in Sub-Saharan Africa (all income levels) in 2006 to that in 2008?
Give a very brief answer. 1.02. What is the ratio of the Rating (1=low 6=high) of Bangladesh in 2006 to that in 2008?
Your answer should be very brief. 1. What is the ratio of the Rating (1=low 6=high) of Cabo Verde in 2006 to that in 2008?
Make the answer very short. 1. What is the ratio of the Rating (1=low 6=high) of East Asia (developing only) in 2006 to that in 2009?
Make the answer very short. 0.94. What is the ratio of the Rating (1=low 6=high) of Sub-Saharan Africa (all income levels) in 2006 to that in 2009?
Ensure brevity in your answer.  1. What is the ratio of the Rating (1=low 6=high) of East Asia (developing only) in 2006 to that in 2010?
Offer a terse response. 0.91. What is the ratio of the Rating (1=low 6=high) in Sub-Saharan Africa (all income levels) in 2006 to that in 2010?
Your response must be concise. 0.97. What is the ratio of the Rating (1=low 6=high) of Bangladesh in 2006 to that in 2010?
Provide a succinct answer. 1. What is the ratio of the Rating (1=low 6=high) in Cabo Verde in 2006 to that in 2010?
Ensure brevity in your answer.  1. What is the ratio of the Rating (1=low 6=high) in East Asia (developing only) in 2006 to that in 2011?
Your answer should be very brief. 0.95. What is the ratio of the Rating (1=low 6=high) of Sub-Saharan Africa (all income levels) in 2006 to that in 2011?
Your answer should be compact. 0.97. What is the ratio of the Rating (1=low 6=high) in Cabo Verde in 2006 to that in 2011?
Make the answer very short. 1.12. What is the ratio of the Rating (1=low 6=high) in Sub-Saharan Africa (all income levels) in 2006 to that in 2012?
Offer a very short reply. 0.98. What is the ratio of the Rating (1=low 6=high) of Sub-Saharan Africa (all income levels) in 2006 to that in 2013?
Ensure brevity in your answer.  0.98. What is the ratio of the Rating (1=low 6=high) of Bangladesh in 2006 to that in 2013?
Your answer should be very brief. 1. What is the ratio of the Rating (1=low 6=high) of Cabo Verde in 2006 to that in 2013?
Give a very brief answer. 1.12. What is the ratio of the Rating (1=low 6=high) in East Asia (developing only) in 2007 to that in 2008?
Keep it short and to the point. 1. What is the ratio of the Rating (1=low 6=high) in Sub-Saharan Africa (all income levels) in 2007 to that in 2008?
Offer a very short reply. 1.02. What is the ratio of the Rating (1=low 6=high) in Cabo Verde in 2007 to that in 2008?
Ensure brevity in your answer.  1. What is the ratio of the Rating (1=low 6=high) in East Asia (developing only) in 2007 to that in 2009?
Ensure brevity in your answer.  0.95. What is the ratio of the Rating (1=low 6=high) in Bangladesh in 2007 to that in 2009?
Keep it short and to the point. 1. What is the ratio of the Rating (1=low 6=high) of Cabo Verde in 2007 to that in 2009?
Ensure brevity in your answer.  1. What is the ratio of the Rating (1=low 6=high) of East Asia (developing only) in 2007 to that in 2010?
Give a very brief answer. 0.91. What is the ratio of the Rating (1=low 6=high) of Sub-Saharan Africa (all income levels) in 2007 to that in 2010?
Make the answer very short. 0.97. What is the ratio of the Rating (1=low 6=high) of Cabo Verde in 2007 to that in 2010?
Your response must be concise. 1. What is the ratio of the Rating (1=low 6=high) of East Asia (developing only) in 2007 to that in 2011?
Your response must be concise. 0.96. What is the ratio of the Rating (1=low 6=high) of Sub-Saharan Africa (all income levels) in 2007 to that in 2011?
Offer a very short reply. 0.97. What is the ratio of the Rating (1=low 6=high) in Bangladesh in 2007 to that in 2011?
Your response must be concise. 1. What is the ratio of the Rating (1=low 6=high) of Sub-Saharan Africa (all income levels) in 2007 to that in 2012?
Offer a very short reply. 0.98. What is the ratio of the Rating (1=low 6=high) of Cabo Verde in 2007 to that in 2012?
Give a very brief answer. 1.12. What is the ratio of the Rating (1=low 6=high) in East Asia (developing only) in 2007 to that in 2013?
Provide a short and direct response. 1. What is the ratio of the Rating (1=low 6=high) in Sub-Saharan Africa (all income levels) in 2007 to that in 2013?
Make the answer very short. 0.98. What is the ratio of the Rating (1=low 6=high) in Bangladesh in 2007 to that in 2013?
Keep it short and to the point. 1. What is the ratio of the Rating (1=low 6=high) in East Asia (developing only) in 2008 to that in 2009?
Ensure brevity in your answer.  0.95. What is the ratio of the Rating (1=low 6=high) in Sub-Saharan Africa (all income levels) in 2008 to that in 2009?
Your answer should be compact. 0.98. What is the ratio of the Rating (1=low 6=high) of Cabo Verde in 2008 to that in 2009?
Provide a short and direct response. 1. What is the ratio of the Rating (1=low 6=high) of East Asia (developing only) in 2008 to that in 2010?
Your response must be concise. 0.91. What is the ratio of the Rating (1=low 6=high) of Sub-Saharan Africa (all income levels) in 2008 to that in 2010?
Your answer should be compact. 0.96. What is the ratio of the Rating (1=low 6=high) of Bangladesh in 2008 to that in 2010?
Give a very brief answer. 1. What is the ratio of the Rating (1=low 6=high) of East Asia (developing only) in 2008 to that in 2011?
Your answer should be compact. 0.96. What is the ratio of the Rating (1=low 6=high) of Sub-Saharan Africa (all income levels) in 2008 to that in 2011?
Your response must be concise. 0.95. What is the ratio of the Rating (1=low 6=high) of Sub-Saharan Africa (all income levels) in 2008 to that in 2012?
Make the answer very short. 0.96. What is the ratio of the Rating (1=low 6=high) in Bangladesh in 2008 to that in 2012?
Give a very brief answer. 1. What is the ratio of the Rating (1=low 6=high) of Cabo Verde in 2008 to that in 2012?
Ensure brevity in your answer.  1.12. What is the ratio of the Rating (1=low 6=high) of East Asia (developing only) in 2008 to that in 2013?
Make the answer very short. 1. What is the ratio of the Rating (1=low 6=high) in Sub-Saharan Africa (all income levels) in 2008 to that in 2013?
Offer a very short reply. 0.96. What is the ratio of the Rating (1=low 6=high) in Bangladesh in 2008 to that in 2013?
Give a very brief answer. 1. What is the ratio of the Rating (1=low 6=high) in East Asia (developing only) in 2009 to that in 2010?
Make the answer very short. 0.96. What is the ratio of the Rating (1=low 6=high) in Sub-Saharan Africa (all income levels) in 2009 to that in 2010?
Make the answer very short. 0.97. What is the ratio of the Rating (1=low 6=high) in East Asia (developing only) in 2009 to that in 2011?
Keep it short and to the point. 1.01. What is the ratio of the Rating (1=low 6=high) of Sub-Saharan Africa (all income levels) in 2009 to that in 2011?
Your response must be concise. 0.96. What is the ratio of the Rating (1=low 6=high) of East Asia (developing only) in 2009 to that in 2012?
Your response must be concise. 1.03. What is the ratio of the Rating (1=low 6=high) in Sub-Saharan Africa (all income levels) in 2009 to that in 2012?
Offer a terse response. 0.98. What is the ratio of the Rating (1=low 6=high) in Bangladesh in 2009 to that in 2012?
Make the answer very short. 1. What is the ratio of the Rating (1=low 6=high) of Cabo Verde in 2009 to that in 2012?
Offer a very short reply. 1.12. What is the ratio of the Rating (1=low 6=high) in East Asia (developing only) in 2009 to that in 2013?
Your response must be concise. 1.06. What is the ratio of the Rating (1=low 6=high) in Sub-Saharan Africa (all income levels) in 2009 to that in 2013?
Give a very brief answer. 0.98. What is the ratio of the Rating (1=low 6=high) of Bangladesh in 2009 to that in 2013?
Offer a very short reply. 1. What is the ratio of the Rating (1=low 6=high) in East Asia (developing only) in 2010 to that in 2011?
Give a very brief answer. 1.05. What is the ratio of the Rating (1=low 6=high) in Bangladesh in 2010 to that in 2011?
Offer a very short reply. 1. What is the ratio of the Rating (1=low 6=high) in East Asia (developing only) in 2010 to that in 2012?
Ensure brevity in your answer.  1.06. What is the ratio of the Rating (1=low 6=high) of Bangladesh in 2010 to that in 2012?
Provide a short and direct response. 1. What is the ratio of the Rating (1=low 6=high) in Cabo Verde in 2010 to that in 2012?
Make the answer very short. 1.12. What is the ratio of the Rating (1=low 6=high) of East Asia (developing only) in 2010 to that in 2013?
Offer a terse response. 1.1. What is the ratio of the Rating (1=low 6=high) in Bangladesh in 2010 to that in 2013?
Give a very brief answer. 1. What is the ratio of the Rating (1=low 6=high) of Sub-Saharan Africa (all income levels) in 2011 to that in 2012?
Provide a short and direct response. 1.01. What is the ratio of the Rating (1=low 6=high) in Bangladesh in 2011 to that in 2012?
Your response must be concise. 1. What is the ratio of the Rating (1=low 6=high) of Cabo Verde in 2011 to that in 2012?
Offer a very short reply. 1. What is the ratio of the Rating (1=low 6=high) in East Asia (developing only) in 2011 to that in 2013?
Ensure brevity in your answer.  1.04. What is the ratio of the Rating (1=low 6=high) in Sub-Saharan Africa (all income levels) in 2011 to that in 2013?
Provide a succinct answer. 1.01. What is the ratio of the Rating (1=low 6=high) of Bangladesh in 2011 to that in 2013?
Offer a terse response. 1. What is the ratio of the Rating (1=low 6=high) in Cabo Verde in 2011 to that in 2013?
Provide a succinct answer. 1. What is the ratio of the Rating (1=low 6=high) in East Asia (developing only) in 2012 to that in 2013?
Offer a very short reply. 1.03. What is the ratio of the Rating (1=low 6=high) in Bangladesh in 2012 to that in 2013?
Make the answer very short. 1. What is the difference between the highest and the second highest Rating (1=low 6=high) in East Asia (developing only)?
Ensure brevity in your answer.  0.14. What is the difference between the highest and the second highest Rating (1=low 6=high) in Sub-Saharan Africa (all income levels)?
Offer a very short reply. 0.03. What is the difference between the highest and the second highest Rating (1=low 6=high) in Bangladesh?
Ensure brevity in your answer.  0. What is the difference between the highest and the second highest Rating (1=low 6=high) of Cabo Verde?
Offer a very short reply. 0. What is the difference between the highest and the lowest Rating (1=low 6=high) in East Asia (developing only)?
Offer a terse response. 0.35. What is the difference between the highest and the lowest Rating (1=low 6=high) of Sub-Saharan Africa (all income levels)?
Your answer should be very brief. 0.17. What is the difference between the highest and the lowest Rating (1=low 6=high) in Bangladesh?
Your answer should be compact. 0. 